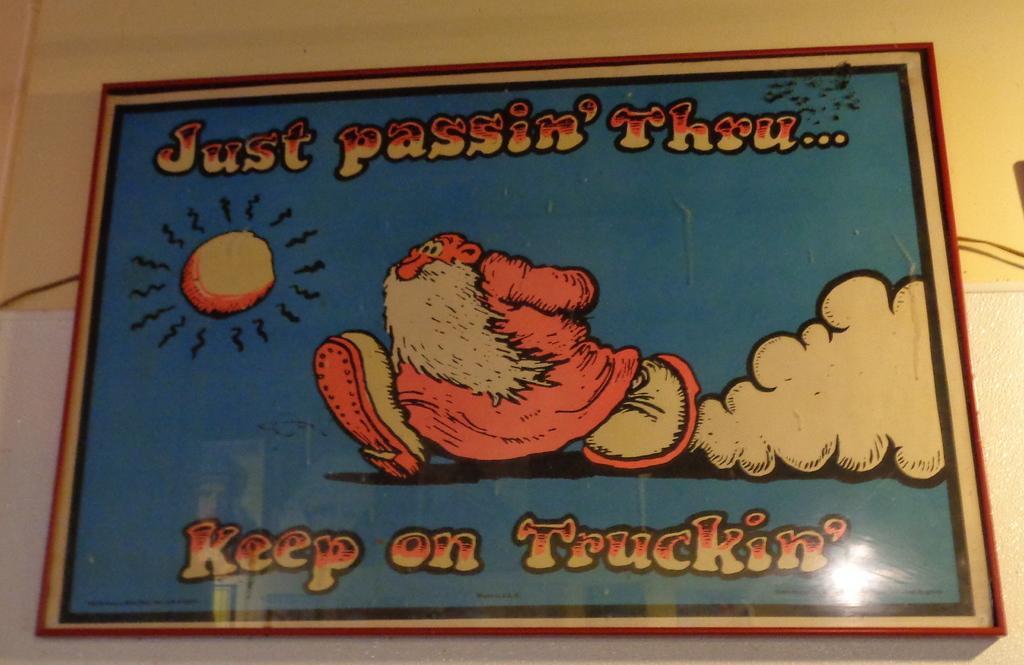Please provide a concise description of this image. In the center of the image there is a frame with a text and the diagram and the frame is attached to the wall. 